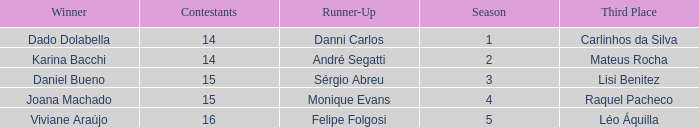In what season did Raquel Pacheco finish in third place? 4.0. 